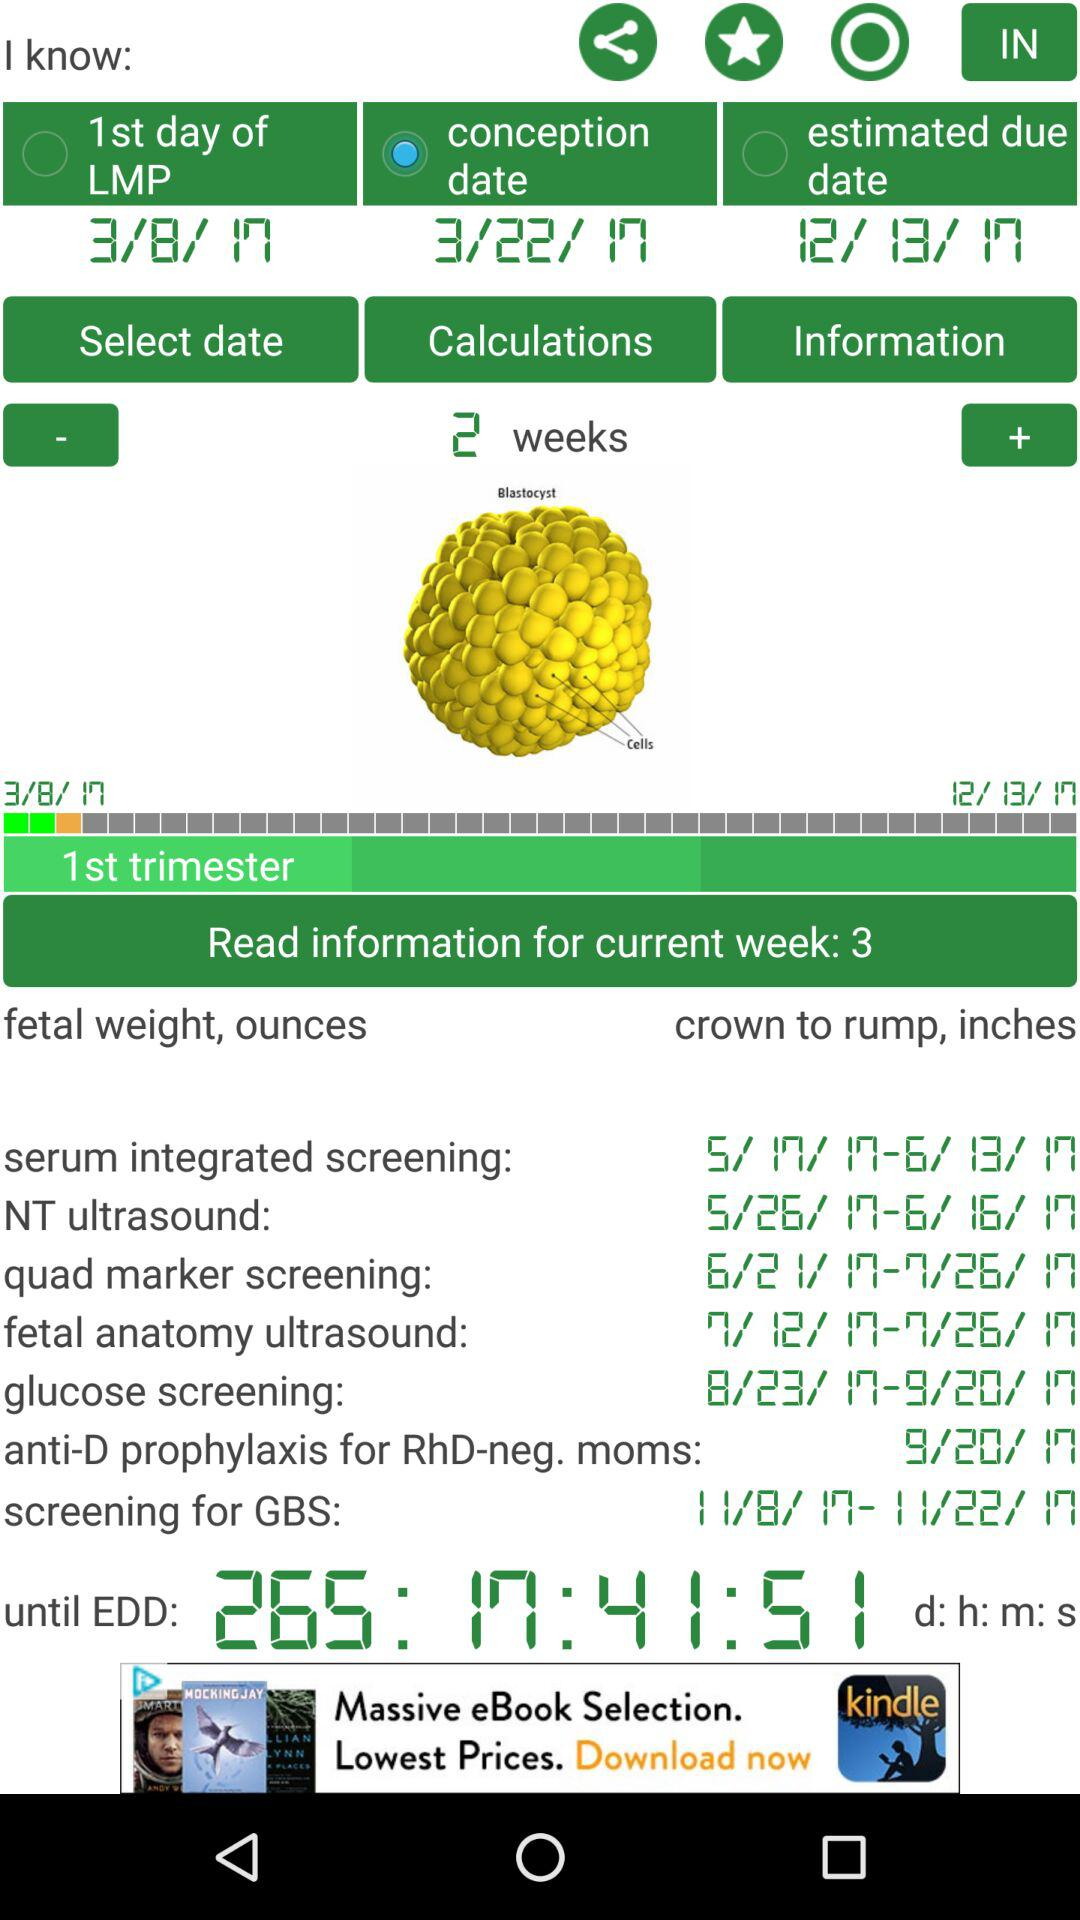How many days until the estimated due date?
Answer the question using a single word or phrase. 265 